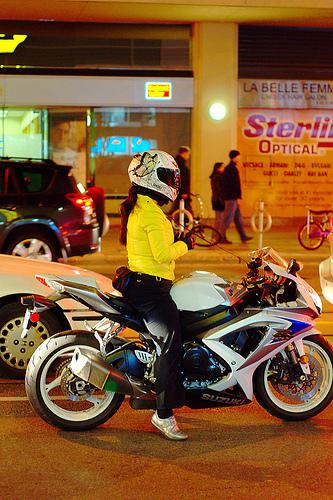Question: who is on the motorcycle?
Choices:
A. A man and a woman.
B. A bird.
C. A rider.
D. A helmet.
Answer with the letter. Answer: C Question: where was the photo taken?
Choices:
A. New York City.
B. Statue of Liberty.
C. Washington Monument.
D. Street.
Answer with the letter. Answer: D Question: what are on?
Choices:
A. Television.
B. Computer.
C. Fan.
D. Lights.
Answer with the letter. Answer: D Question: when was the photo taken?
Choices:
A. At dawn.
B. Nighttime.
C. At dusk.
D. During the day.
Answer with the letter. Answer: B 